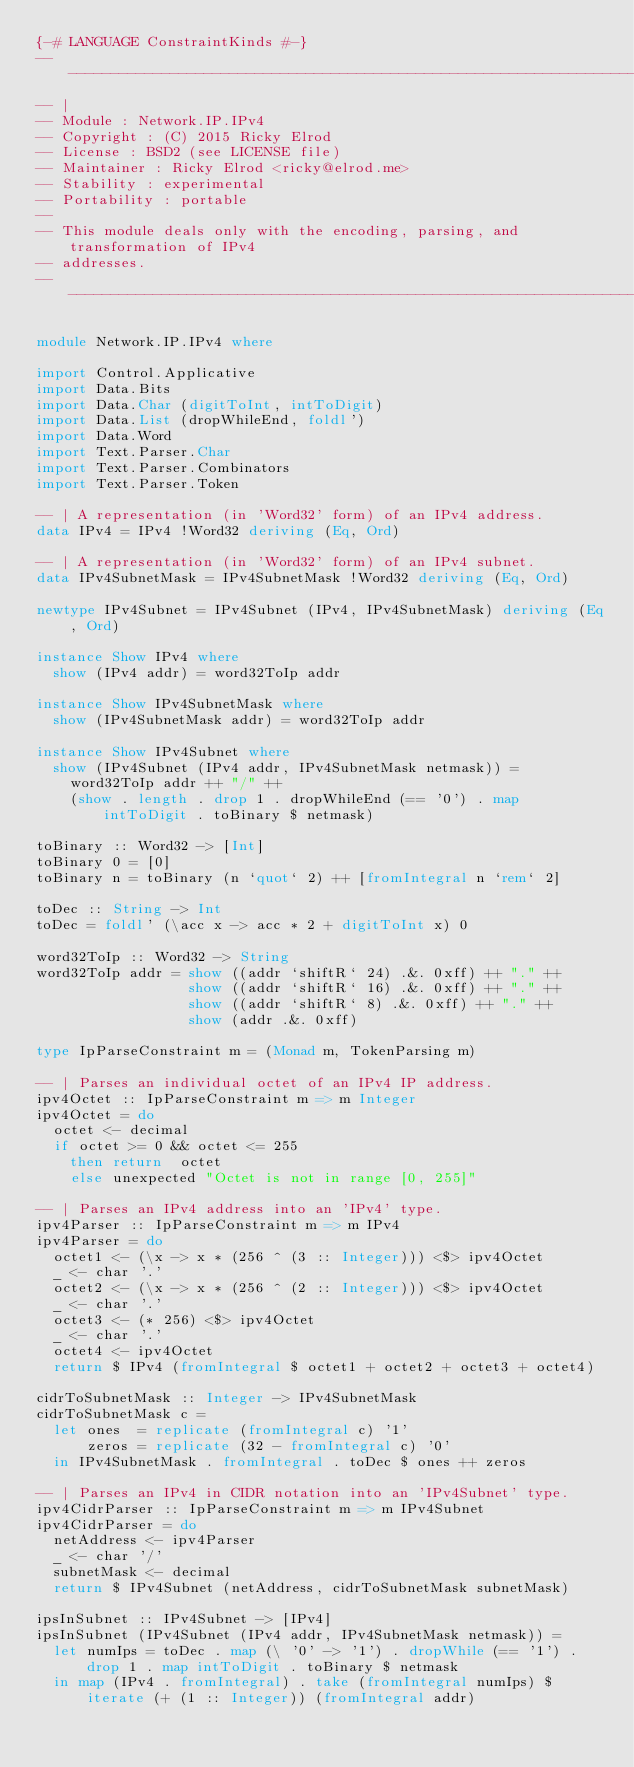<code> <loc_0><loc_0><loc_500><loc_500><_Haskell_>{-# LANGUAGE ConstraintKinds #-}
-----------------------------------------------------------------------------
-- |
-- Module : Network.IP.IPv4
-- Copyright : (C) 2015 Ricky Elrod
-- License : BSD2 (see LICENSE file)
-- Maintainer : Ricky Elrod <ricky@elrod.me>
-- Stability : experimental
-- Portability : portable
--
-- This module deals only with the encoding, parsing, and transformation of IPv4
-- addresses.
----------------------------------------------------------------------------

module Network.IP.IPv4 where

import Control.Applicative
import Data.Bits
import Data.Char (digitToInt, intToDigit)
import Data.List (dropWhileEnd, foldl')
import Data.Word
import Text.Parser.Char
import Text.Parser.Combinators
import Text.Parser.Token

-- | A representation (in 'Word32' form) of an IPv4 address.
data IPv4 = IPv4 !Word32 deriving (Eq, Ord)

-- | A representation (in 'Word32' form) of an IPv4 subnet.
data IPv4SubnetMask = IPv4SubnetMask !Word32 deriving (Eq, Ord)

newtype IPv4Subnet = IPv4Subnet (IPv4, IPv4SubnetMask) deriving (Eq, Ord)

instance Show IPv4 where
  show (IPv4 addr) = word32ToIp addr

instance Show IPv4SubnetMask where
  show (IPv4SubnetMask addr) = word32ToIp addr

instance Show IPv4Subnet where
  show (IPv4Subnet (IPv4 addr, IPv4SubnetMask netmask)) =
    word32ToIp addr ++ "/" ++
    (show . length . drop 1 . dropWhileEnd (== '0') . map intToDigit . toBinary $ netmask)

toBinary :: Word32 -> [Int]
toBinary 0 = [0]
toBinary n = toBinary (n `quot` 2) ++ [fromIntegral n `rem` 2]

toDec :: String -> Int
toDec = foldl' (\acc x -> acc * 2 + digitToInt x) 0

word32ToIp :: Word32 -> String
word32ToIp addr = show ((addr `shiftR` 24) .&. 0xff) ++ "." ++
                  show ((addr `shiftR` 16) .&. 0xff) ++ "." ++
                  show ((addr `shiftR` 8) .&. 0xff) ++ "." ++
                  show (addr .&. 0xff)

type IpParseConstraint m = (Monad m, TokenParsing m)

-- | Parses an individual octet of an IPv4 IP address.
ipv4Octet :: IpParseConstraint m => m Integer
ipv4Octet = do
  octet <- decimal
  if octet >= 0 && octet <= 255
    then return  octet
    else unexpected "Octet is not in range [0, 255]"

-- | Parses an IPv4 address into an 'IPv4' type.
ipv4Parser :: IpParseConstraint m => m IPv4
ipv4Parser = do
  octet1 <- (\x -> x * (256 ^ (3 :: Integer))) <$> ipv4Octet
  _ <- char '.'
  octet2 <- (\x -> x * (256 ^ (2 :: Integer))) <$> ipv4Octet
  _ <- char '.'
  octet3 <- (* 256) <$> ipv4Octet
  _ <- char '.'
  octet4 <- ipv4Octet
  return $ IPv4 (fromIntegral $ octet1 + octet2 + octet3 + octet4)

cidrToSubnetMask :: Integer -> IPv4SubnetMask
cidrToSubnetMask c =
  let ones  = replicate (fromIntegral c) '1'
      zeros = replicate (32 - fromIntegral c) '0'
  in IPv4SubnetMask . fromIntegral . toDec $ ones ++ zeros

-- | Parses an IPv4 in CIDR notation into an 'IPv4Subnet' type.
ipv4CidrParser :: IpParseConstraint m => m IPv4Subnet
ipv4CidrParser = do
  netAddress <- ipv4Parser
  _ <- char '/'
  subnetMask <- decimal
  return $ IPv4Subnet (netAddress, cidrToSubnetMask subnetMask)

ipsInSubnet :: IPv4Subnet -> [IPv4]
ipsInSubnet (IPv4Subnet (IPv4 addr, IPv4SubnetMask netmask)) =
  let numIps = toDec . map (\ '0' -> '1') . dropWhile (== '1') . drop 1 . map intToDigit . toBinary $ netmask
  in map (IPv4 . fromIntegral) . take (fromIntegral numIps) $ iterate (+ (1 :: Integer)) (fromIntegral addr)
</code> 